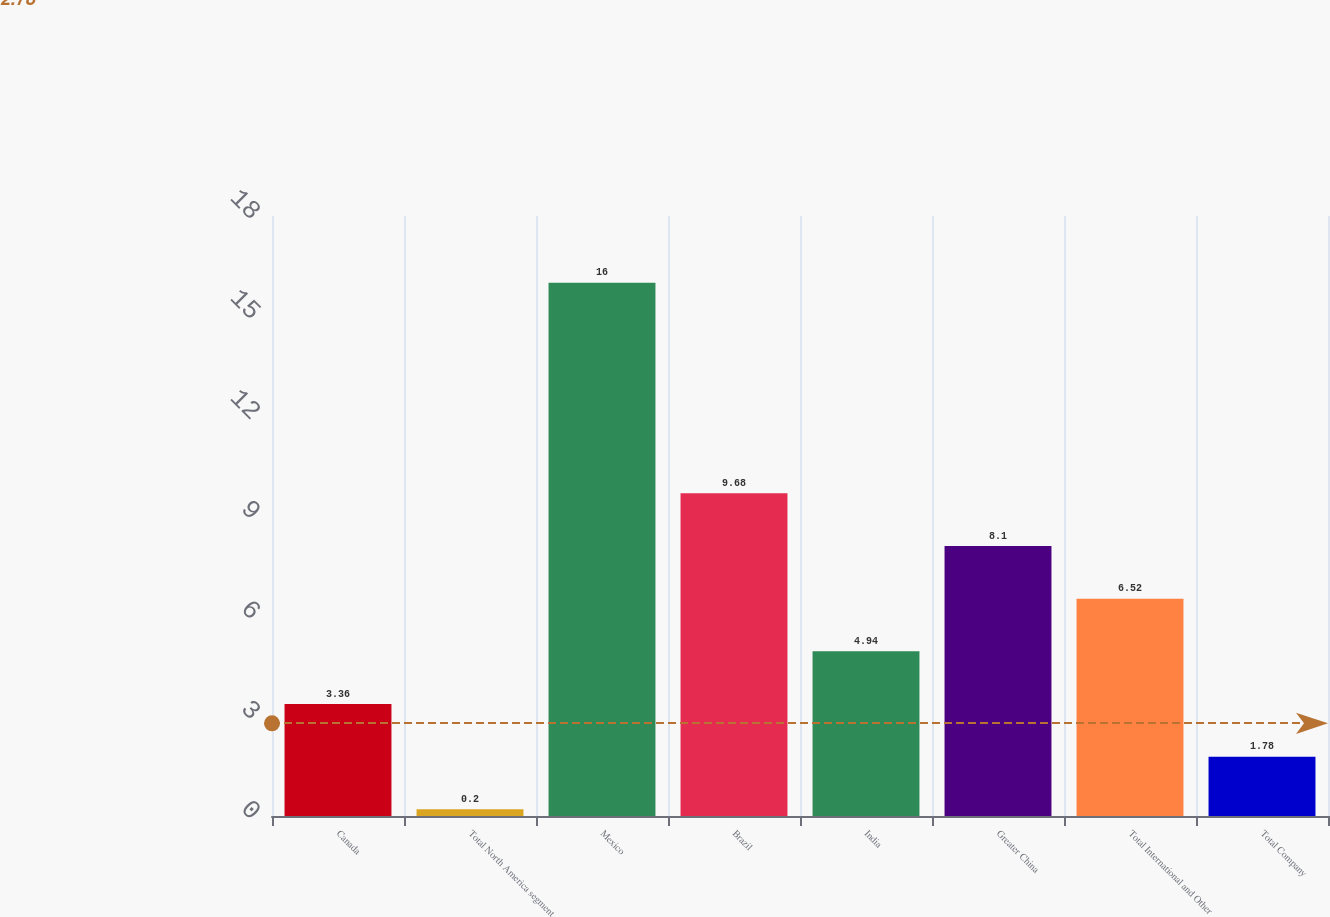Convert chart to OTSL. <chart><loc_0><loc_0><loc_500><loc_500><bar_chart><fcel>Canada<fcel>Total North America segment<fcel>Mexico<fcel>Brazil<fcel>India<fcel>Greater China<fcel>Total International and Other<fcel>Total Company<nl><fcel>3.36<fcel>0.2<fcel>16<fcel>9.68<fcel>4.94<fcel>8.1<fcel>6.52<fcel>1.78<nl></chart> 